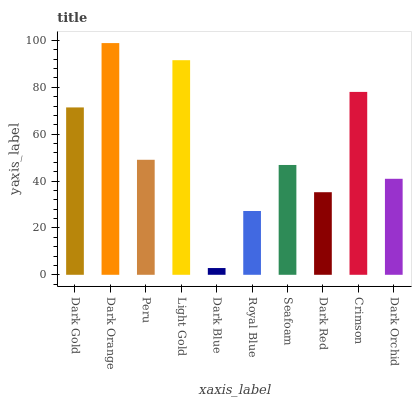Is Dark Blue the minimum?
Answer yes or no. Yes. Is Dark Orange the maximum?
Answer yes or no. Yes. Is Peru the minimum?
Answer yes or no. No. Is Peru the maximum?
Answer yes or no. No. Is Dark Orange greater than Peru?
Answer yes or no. Yes. Is Peru less than Dark Orange?
Answer yes or no. Yes. Is Peru greater than Dark Orange?
Answer yes or no. No. Is Dark Orange less than Peru?
Answer yes or no. No. Is Peru the high median?
Answer yes or no. Yes. Is Seafoam the low median?
Answer yes or no. Yes. Is Dark Red the high median?
Answer yes or no. No. Is Dark Orchid the low median?
Answer yes or no. No. 